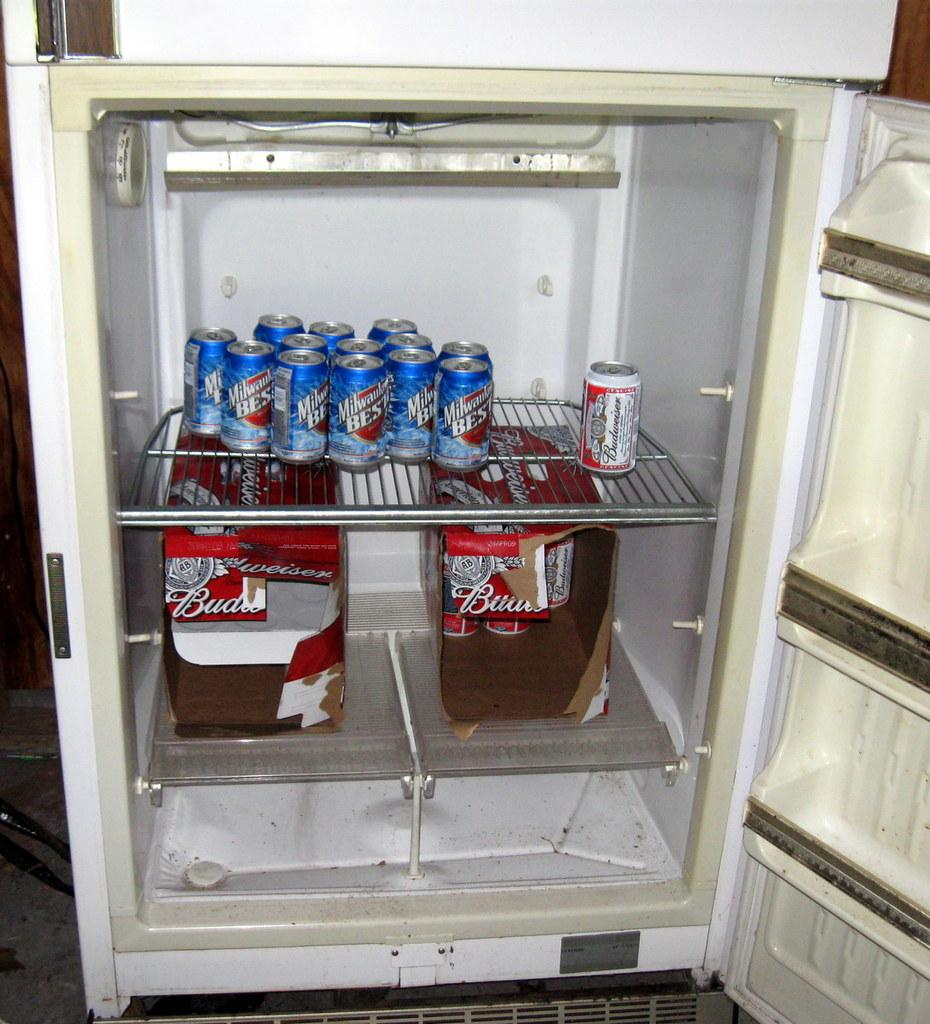Provide a one-sentence caption for the provided image. An open refrigerator that contains cans of Milwaukee's Best and Budweiser beer. 